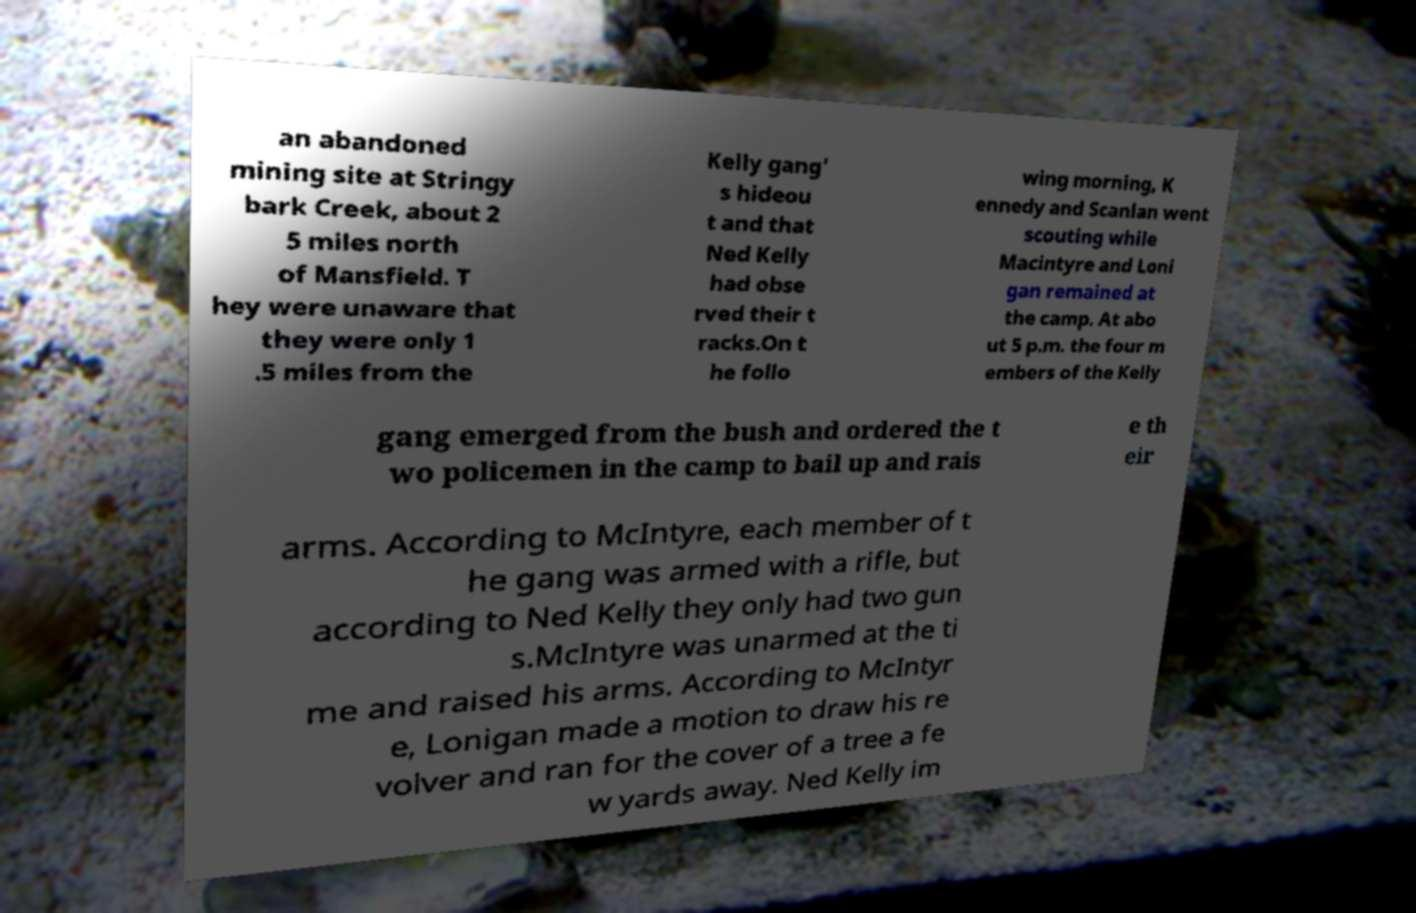Can you accurately transcribe the text from the provided image for me? an abandoned mining site at Stringy bark Creek, about 2 5 miles north of Mansfield. T hey were unaware that they were only 1 .5 miles from the Kelly gang' s hideou t and that Ned Kelly had obse rved their t racks.On t he follo wing morning, K ennedy and Scanlan went scouting while Macintyre and Loni gan remained at the camp. At abo ut 5 p.m. the four m embers of the Kelly gang emerged from the bush and ordered the t wo policemen in the camp to bail up and rais e th eir arms. According to McIntyre, each member of t he gang was armed with a rifle, but according to Ned Kelly they only had two gun s.McIntyre was unarmed at the ti me and raised his arms. According to McIntyr e, Lonigan made a motion to draw his re volver and ran for the cover of a tree a fe w yards away. Ned Kelly im 